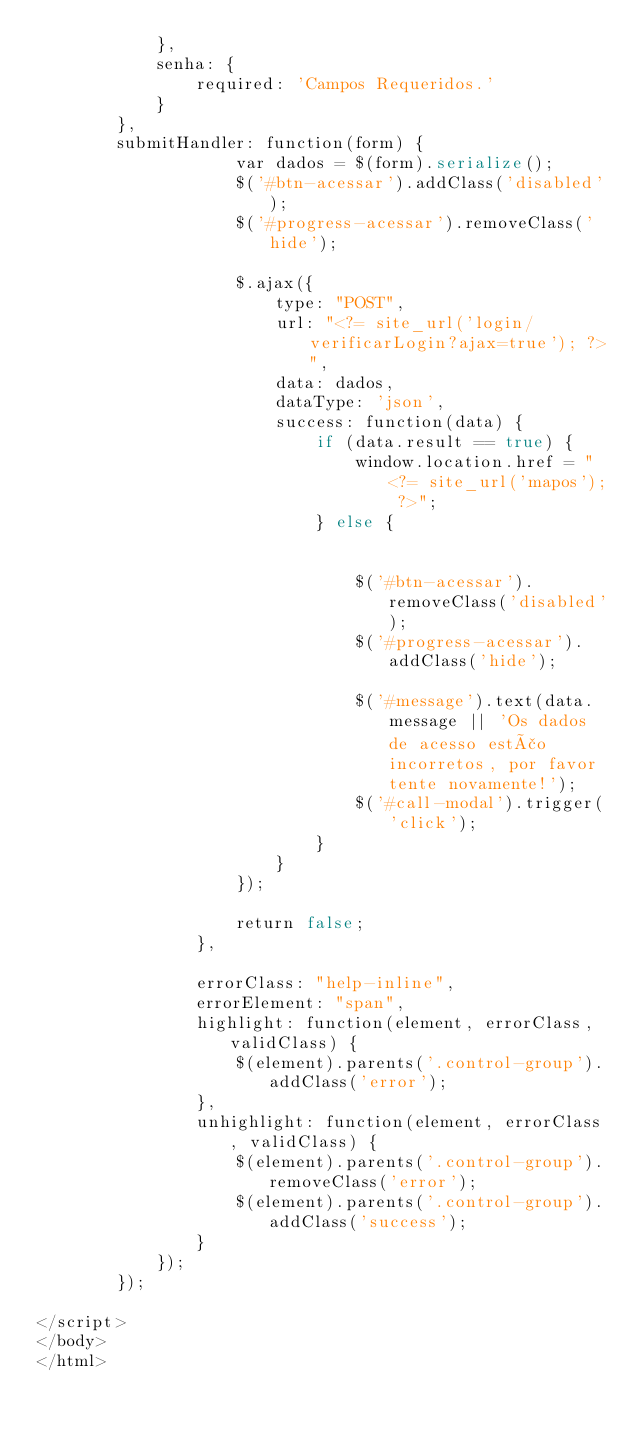<code> <loc_0><loc_0><loc_500><loc_500><_PHP_>            },
            senha: {
                required: 'Campos Requeridos.'
            }
        },
        submitHandler: function(form) {
                    var dados = $(form).serialize();
                    $('#btn-acessar').addClass('disabled');
                    $('#progress-acessar').removeClass('hide');

                    $.ajax({
                        type: "POST",
                        url: "<?= site_url('login/verificarLogin?ajax=true'); ?>",
                        data: dados,
                        dataType: 'json',
                        success: function(data) {
                            if (data.result == true) {
                                window.location.href = "<?= site_url('mapos'); ?>";
                            } else {


                                $('#btn-acessar').removeClass('disabled');
                                $('#progress-acessar').addClass('hide');

                                $('#message').text(data.message || 'Os dados de acesso estão incorretos, por favor tente novamente!');
                                $('#call-modal').trigger('click');
                            }
                        }
                    });

                    return false;
                },

                errorClass: "help-inline",
                errorElement: "span",
                highlight: function(element, errorClass, validClass) {
                    $(element).parents('.control-group').addClass('error');
                },
                unhighlight: function(element, errorClass, validClass) {
                    $(element).parents('.control-group').removeClass('error');
                    $(element).parents('.control-group').addClass('success');
                }
            });
        });

</script>
</body>
</html>
</code> 